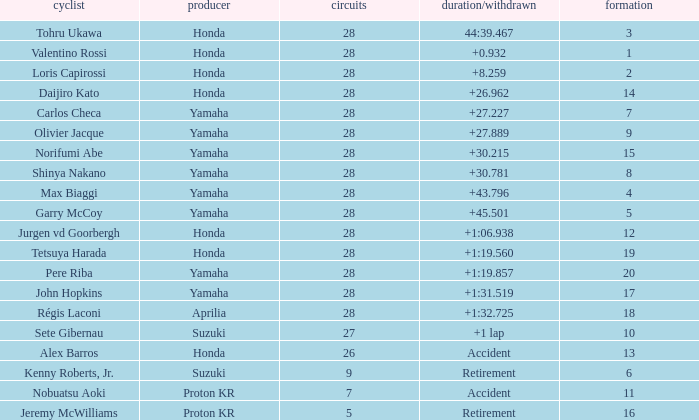Which Grid has Laps larger than 26, and a Time/Retired of 44:39.467? 3.0. 